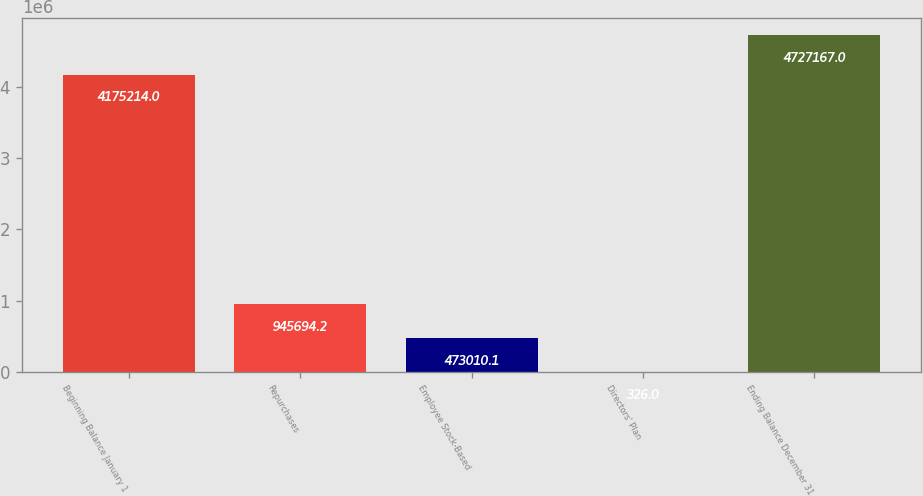Convert chart. <chart><loc_0><loc_0><loc_500><loc_500><bar_chart><fcel>Beginning Balance January 1<fcel>Repurchases<fcel>Employee Stock-Based<fcel>Directors' Plan<fcel>Ending Balance December 31<nl><fcel>4.17521e+06<fcel>945694<fcel>473010<fcel>326<fcel>4.72717e+06<nl></chart> 